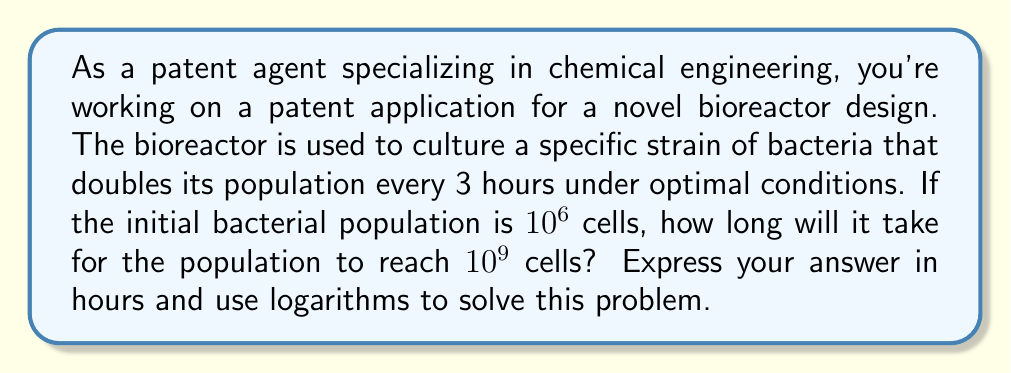Provide a solution to this math problem. Let's approach this step-by-step using logarithms:

1) Let $t$ be the time in hours and $N(t)$ be the number of bacteria at time $t$.

2) The initial population is $N(0) = 10^6$ cells.

3) The population doubles every 3 hours, so we can express this as an exponential growth function:

   $N(t) = 10^6 \cdot 2^{t/3}$

4) We want to find $t$ when $N(t) = 10^9$. Let's set up the equation:

   $10^9 = 10^6 \cdot 2^{t/3}$

5) Divide both sides by $10^6$:

   $10^3 = 2^{t/3}$

6) Now, let's take the logarithm (base 2) of both sides:

   $\log_2(10^3) = \log_2(2^{t/3})$

7) The right side simplifies due to the logarithm rule $\log_a(a^x) = x$:

   $\log_2(10^3) = t/3$

8) Multiply both sides by 3:

   $3 \log_2(10^3) = t$

9) To calculate $\log_2(10^3)$, we can use the change of base formula:

   $\log_2(10^3) = \frac{\log(10^3)}{\log(2)} = \frac{3\log(10)}{\log(2)} \approx 9.97$

10) Therefore:

    $t = 3 \cdot 9.97 \approx 29.91$ hours
Answer: It will take approximately 29.91 hours for the bacterial population to reach $10^9$ cells. 